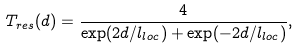<formula> <loc_0><loc_0><loc_500><loc_500>T _ { r e s } ( d ) = \frac { 4 } { \exp ( 2 d / l _ { l o c } ) + \exp ( - 2 d / l _ { l o c } ) } ,</formula> 